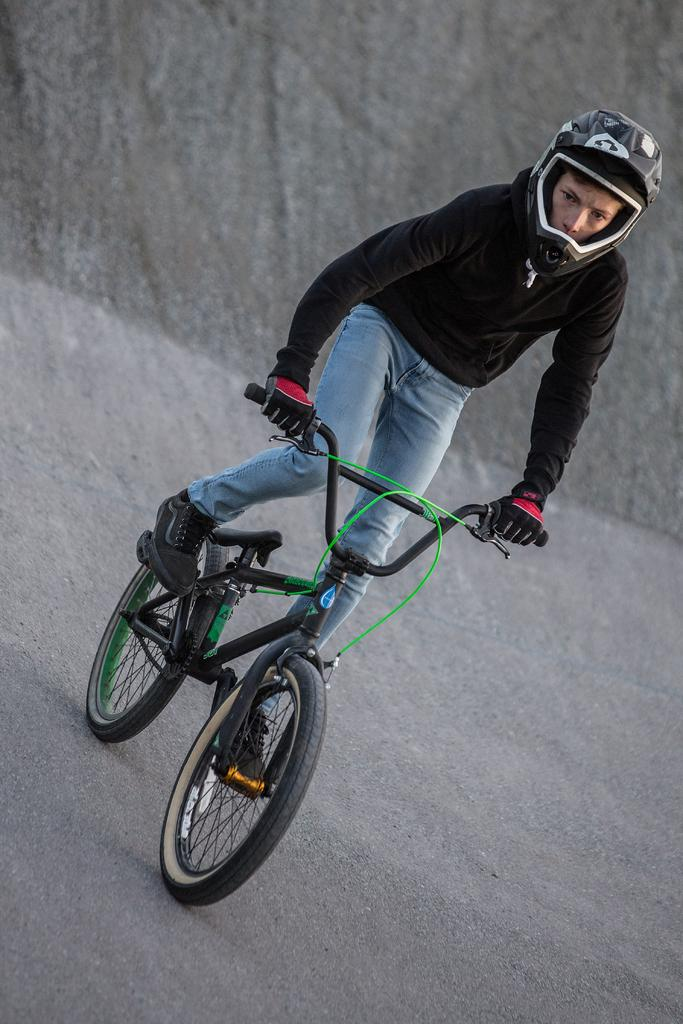What is the main subject of the image? There is a person in the image. What is the person doing in the image? The person is riding a bicycle. Where is the bicycle located in the image? The bicycle is on a path. What type of harmony is the person trying to achieve with the servant in the image? There is no servant present in the image, and therefore no such interaction can be observed. 